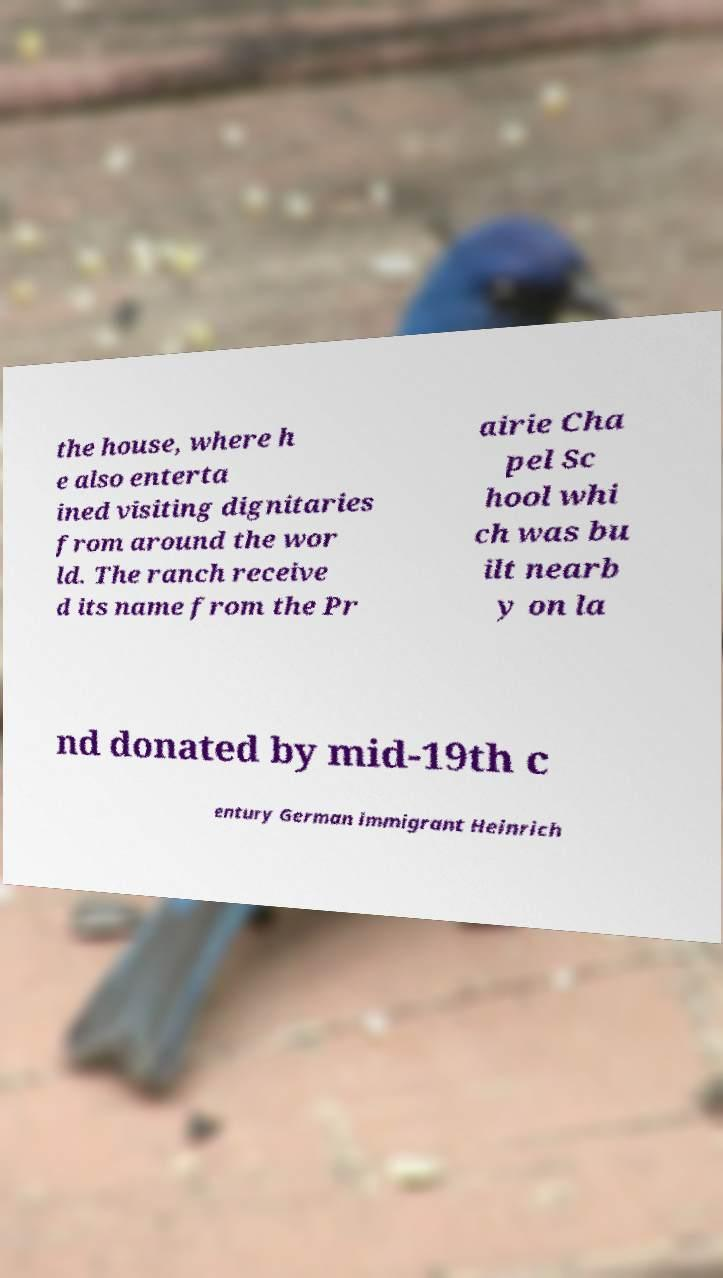Please read and relay the text visible in this image. What does it say? the house, where h e also enterta ined visiting dignitaries from around the wor ld. The ranch receive d its name from the Pr airie Cha pel Sc hool whi ch was bu ilt nearb y on la nd donated by mid-19th c entury German immigrant Heinrich 